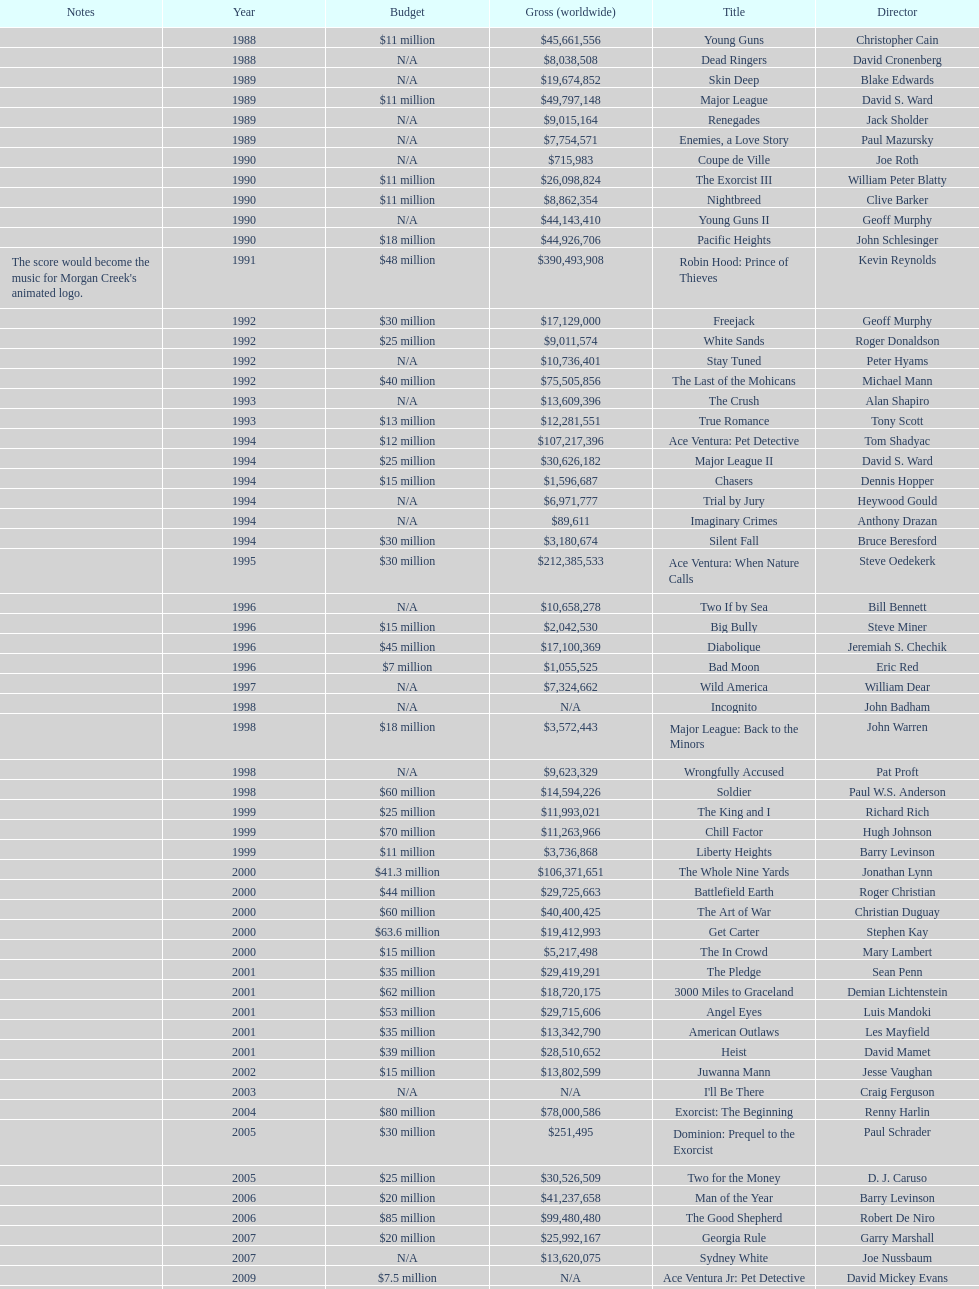Which morgan creek film grossed the most worldwide? Robin Hood: Prince of Thieves. 